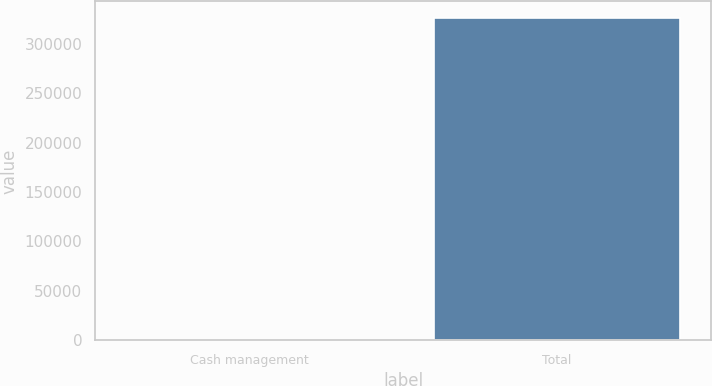Convert chart to OTSL. <chart><loc_0><loc_0><loc_500><loc_500><bar_chart><fcel>Cash management<fcel>Total<nl><fcel>430<fcel>326364<nl></chart> 